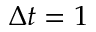<formula> <loc_0><loc_0><loc_500><loc_500>\Delta t = 1</formula> 